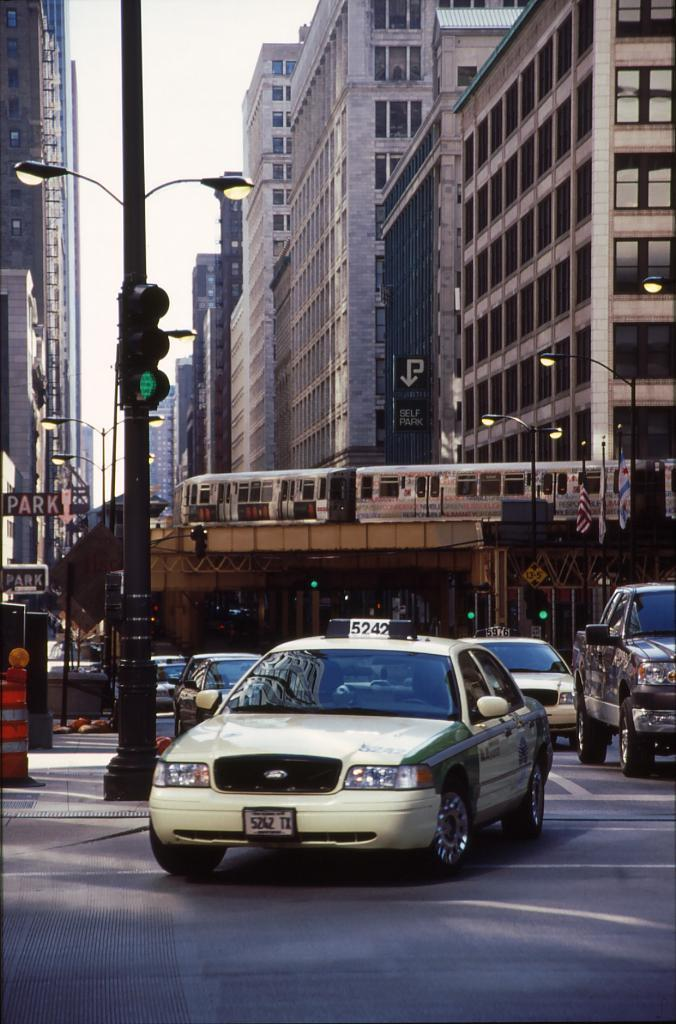<image>
Summarize the visual content of the image. the number 5242 is on the top of the taxi 